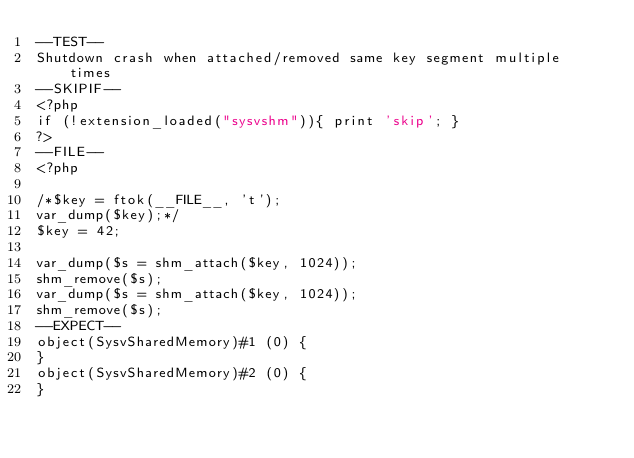<code> <loc_0><loc_0><loc_500><loc_500><_PHP_>--TEST--
Shutdown crash when attached/removed same key segment multiple times
--SKIPIF--
<?php
if (!extension_loaded("sysvshm")){ print 'skip'; }
?>
--FILE--
<?php

/*$key = ftok(__FILE__, 't');
var_dump($key);*/
$key = 42;

var_dump($s = shm_attach($key, 1024));
shm_remove($s);
var_dump($s = shm_attach($key, 1024));
shm_remove($s);
--EXPECT--
object(SysvSharedMemory)#1 (0) {
}
object(SysvSharedMemory)#2 (0) {
}
</code> 